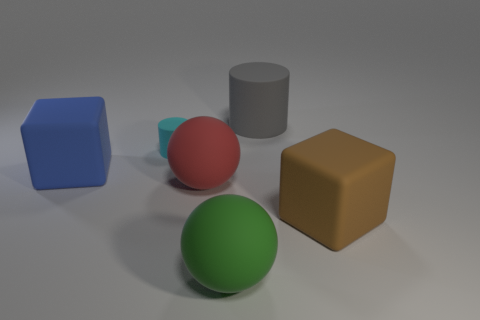There is a cyan object; what shape is it?
Your answer should be very brief. Cylinder. How big is the rubber cylinder that is right of the large rubber ball in front of the large cube that is in front of the large red matte thing?
Offer a very short reply. Large. What number of other things are the same shape as the small cyan object?
Your answer should be compact. 1. Is the shape of the large thing that is to the right of the gray rubber thing the same as the blue thing to the left of the brown matte cube?
Your answer should be compact. Yes. What number of cylinders are either large green matte objects or big blue matte things?
Your answer should be very brief. 0. What material is the cube that is in front of the block that is left of the cylinder that is in front of the gray matte object?
Make the answer very short. Rubber. How many other things are the same size as the blue matte thing?
Offer a terse response. 4. Is the number of brown blocks left of the gray matte object greater than the number of blue rubber cubes?
Give a very brief answer. No. Is there a big matte cube of the same color as the tiny cylinder?
Your answer should be very brief. No. What is the color of the cylinder that is the same size as the blue cube?
Keep it short and to the point. Gray. 